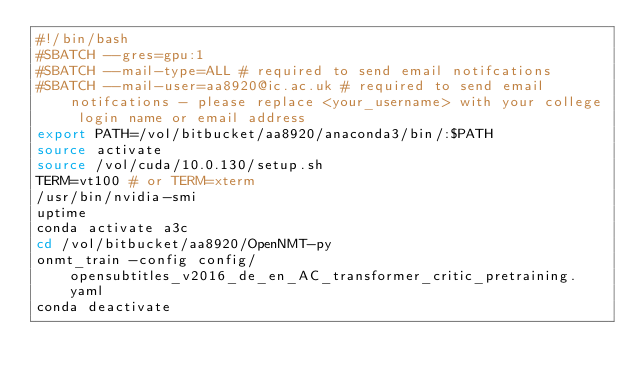<code> <loc_0><loc_0><loc_500><loc_500><_Bash_>#!/bin/bash
#SBATCH --gres=gpu:1
#SBATCH --mail-type=ALL # required to send email notifcations
#SBATCH --mail-user=aa8920@ic.ac.uk # required to send email notifcations - please replace <your_username> with your college login name or email address
export PATH=/vol/bitbucket/aa8920/anaconda3/bin/:$PATH
source activate
source /vol/cuda/10.0.130/setup.sh
TERM=vt100 # or TERM=xterm
/usr/bin/nvidia-smi
uptime
conda activate a3c
cd /vol/bitbucket/aa8920/OpenNMT-py
onmt_train -config config/opensubtitles_v2016_de_en_AC_transformer_critic_pretraining.yaml
conda deactivate</code> 